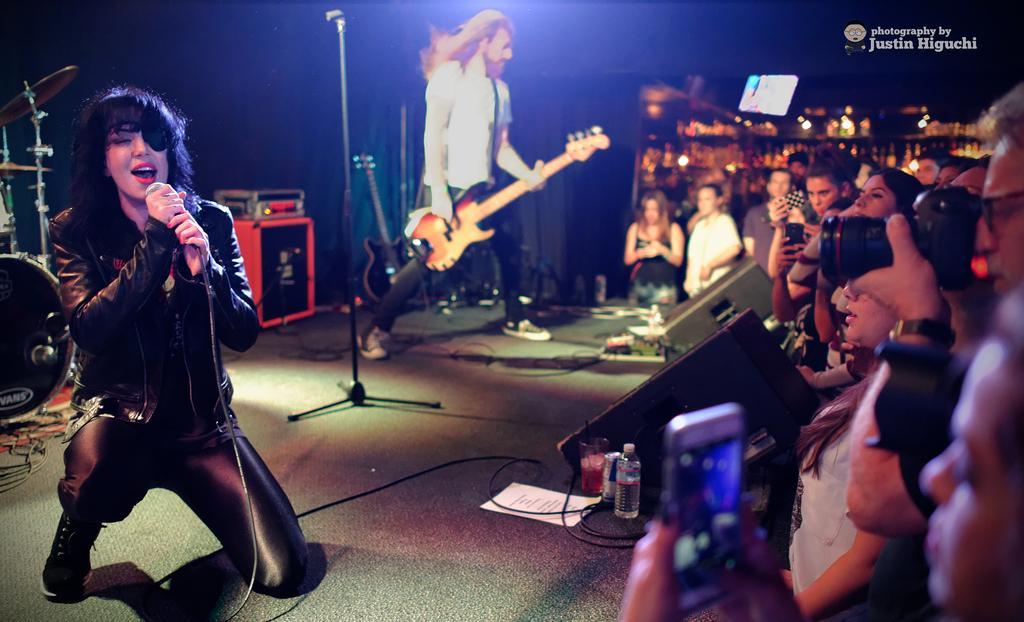Please provide a concise description of this image. In this image there are group of people. On the stage there is a woman singing and other person is playing a guitar. 